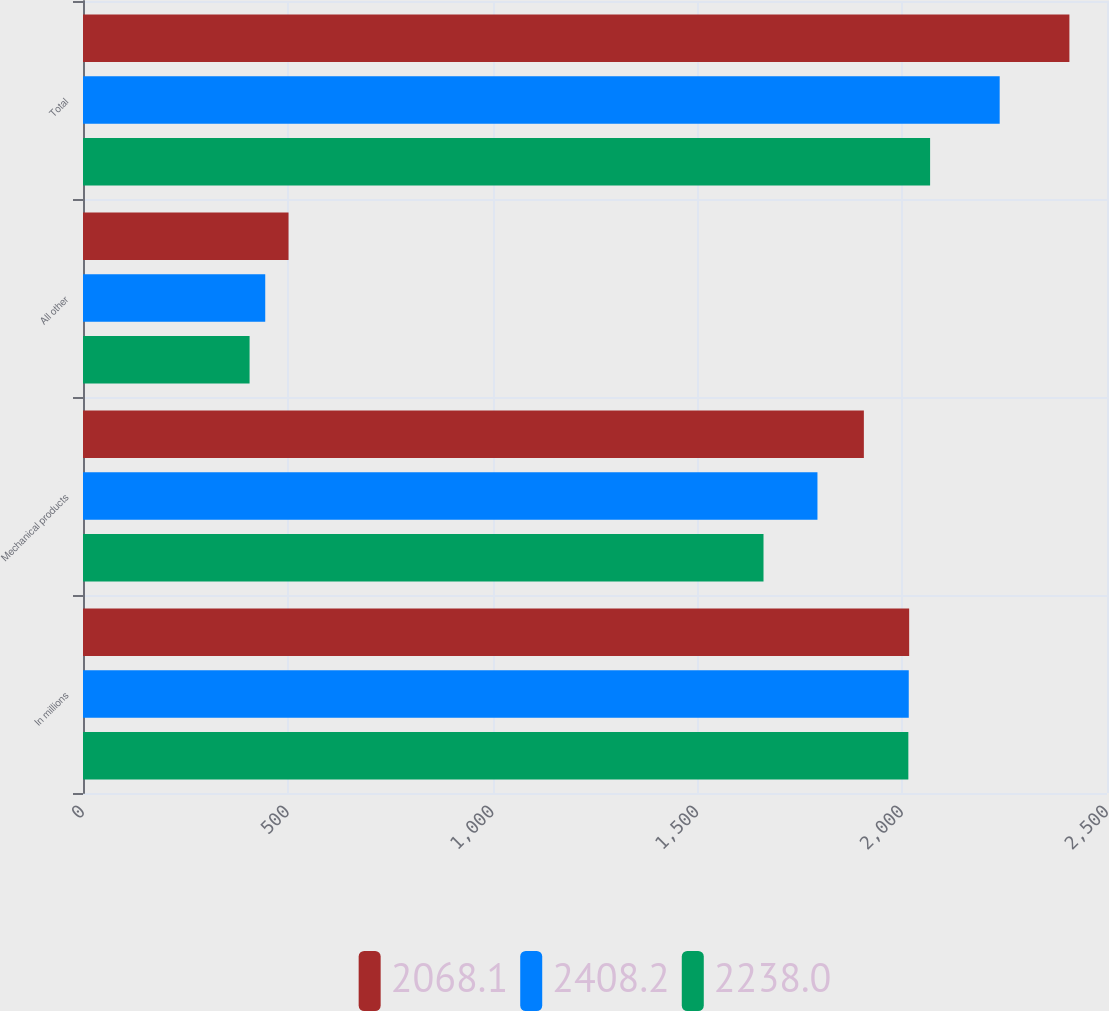Convert chart to OTSL. <chart><loc_0><loc_0><loc_500><loc_500><stacked_bar_chart><ecel><fcel>In millions<fcel>Mechanical products<fcel>All other<fcel>Total<nl><fcel>2068.1<fcel>2017<fcel>1906.4<fcel>501.8<fcel>2408.2<nl><fcel>2408.2<fcel>2016<fcel>1793.1<fcel>444.9<fcel>2238<nl><fcel>2238<fcel>2015<fcel>1661.4<fcel>406.7<fcel>2068.1<nl></chart> 